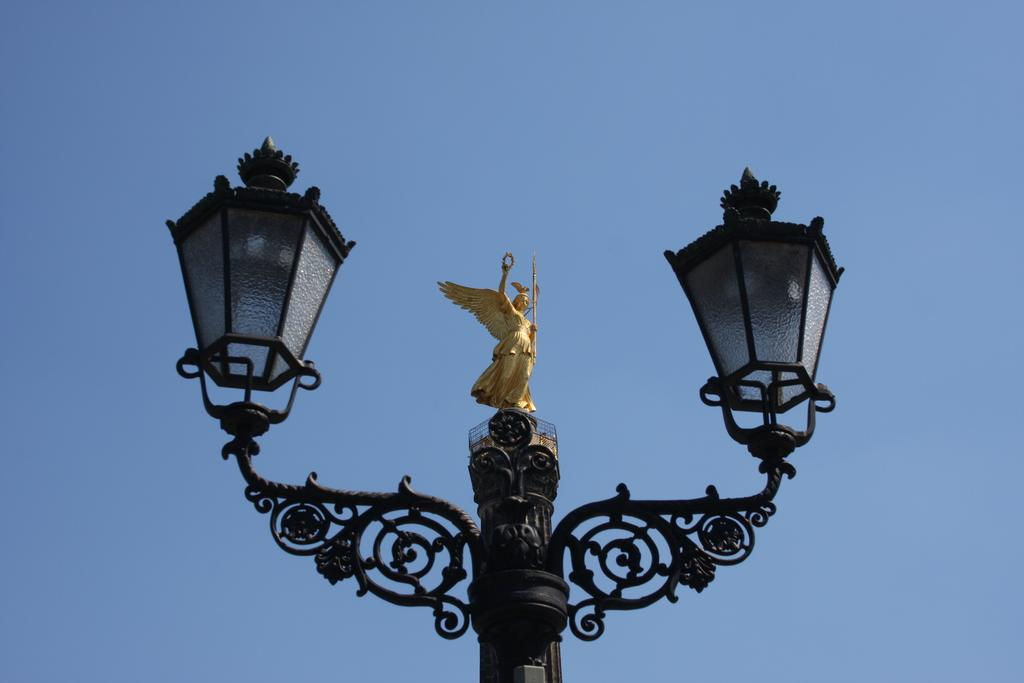What is the main object in the image? There is a pole in the image. What is on the pole? There is a sculpture on the pole. What else can be seen in the image besides the pole and sculpture? There are lights in the image. What is visible in the background of the image? The sky is visible in the background of the image. Can you hear the voice of the sculpture in the image? There is no voice present in the image, as it is a sculpture on a pole. What is the sculpture rubbing against in the image? There is no rubbing action depicted in the image; the sculpture is simply on the pole. 